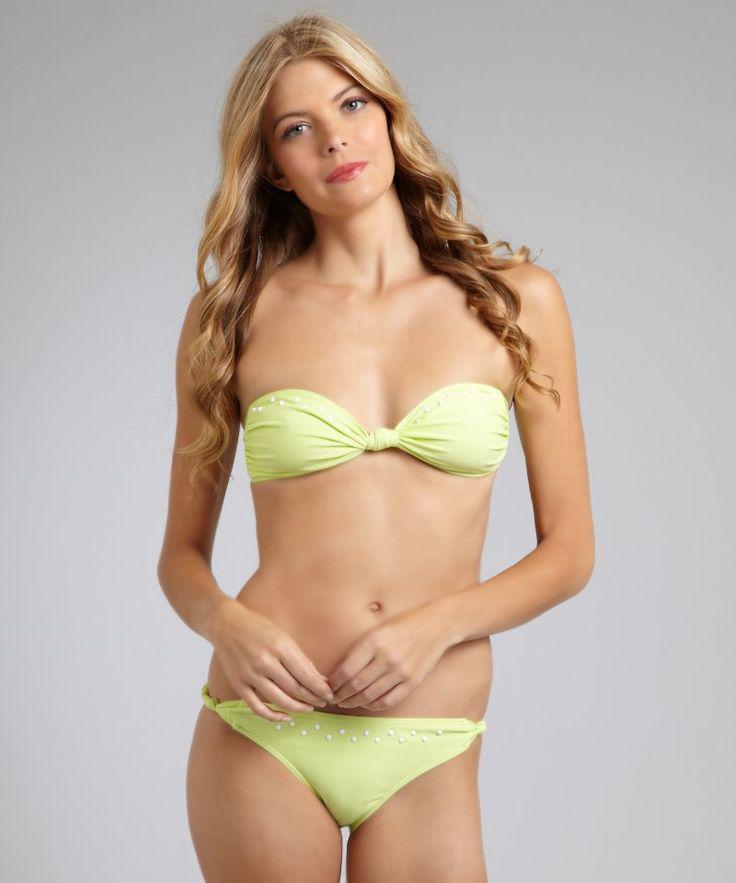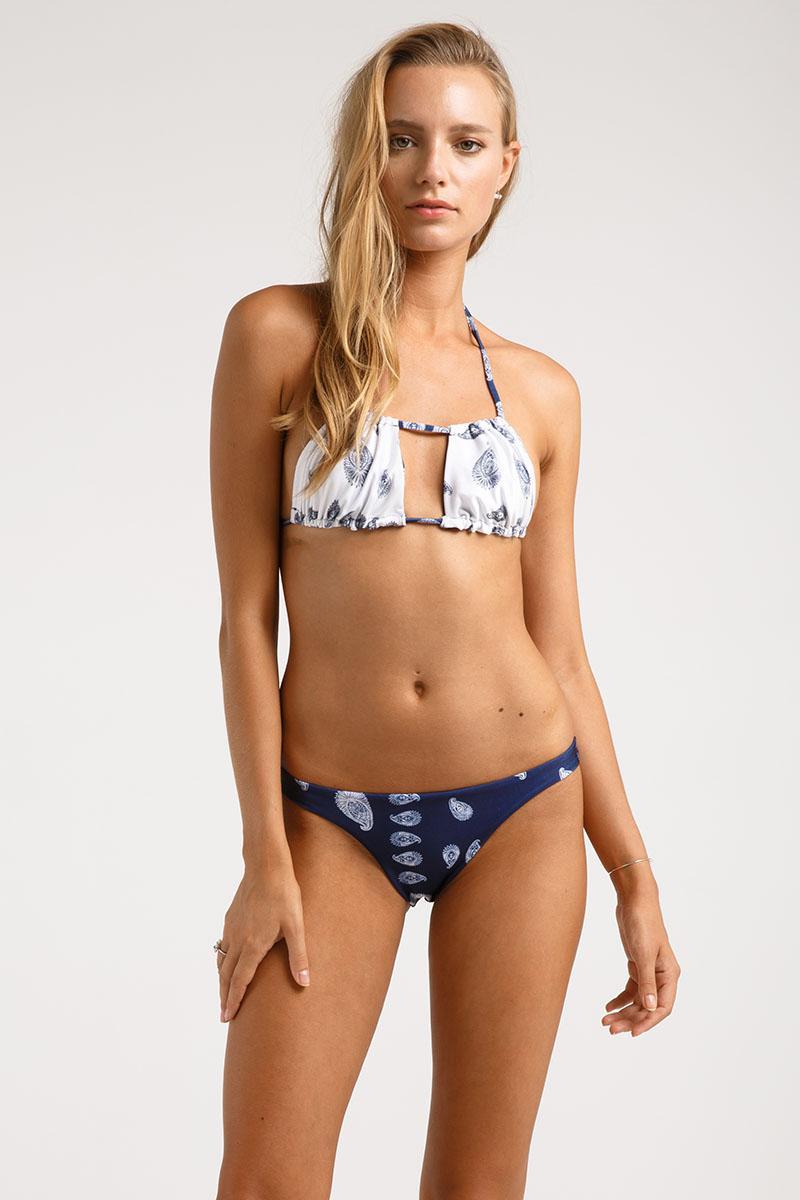The first image is the image on the left, the second image is the image on the right. For the images shown, is this caption "A blonde model wears a light green bikini in one image." true? Answer yes or no. Yes. The first image is the image on the left, the second image is the image on the right. Evaluate the accuracy of this statement regarding the images: "There is one green bikini". Is it true? Answer yes or no. Yes. 